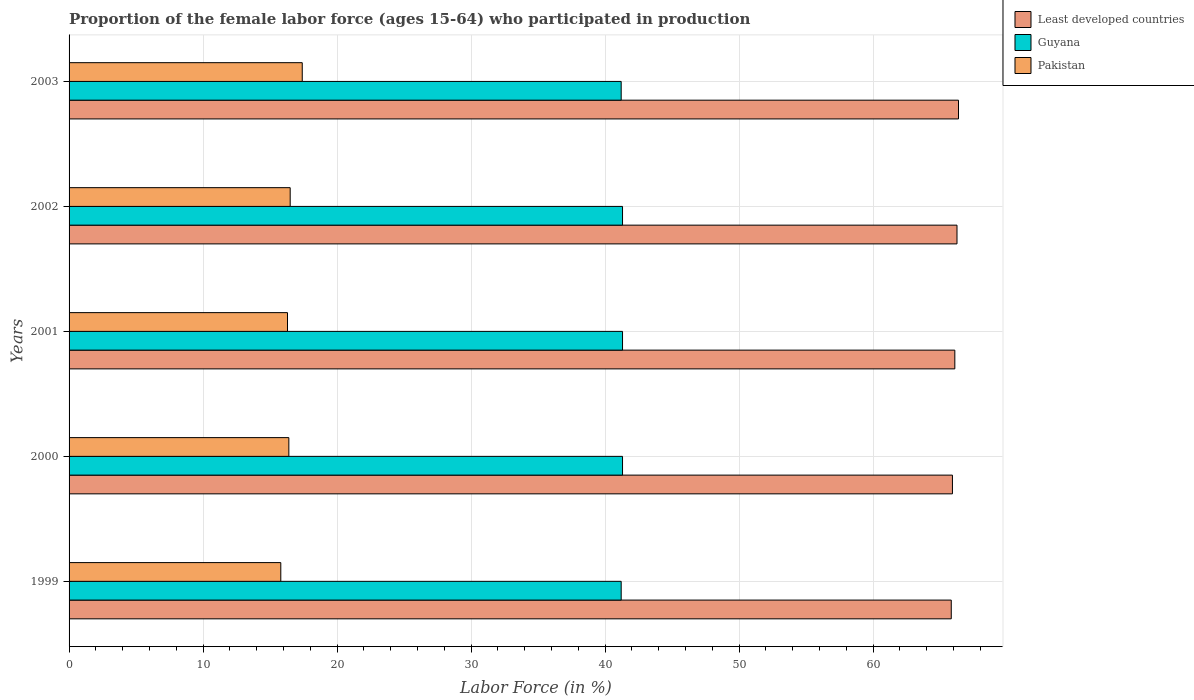Are the number of bars on each tick of the Y-axis equal?
Give a very brief answer. Yes. How many bars are there on the 3rd tick from the top?
Ensure brevity in your answer.  3. How many bars are there on the 3rd tick from the bottom?
Offer a terse response. 3. In how many cases, is the number of bars for a given year not equal to the number of legend labels?
Make the answer very short. 0. What is the proportion of the female labor force who participated in production in Least developed countries in 2000?
Provide a succinct answer. 65.92. Across all years, what is the maximum proportion of the female labor force who participated in production in Pakistan?
Your response must be concise. 17.4. Across all years, what is the minimum proportion of the female labor force who participated in production in Guyana?
Ensure brevity in your answer.  41.2. In which year was the proportion of the female labor force who participated in production in Least developed countries maximum?
Provide a short and direct response. 2003. What is the total proportion of the female labor force who participated in production in Least developed countries in the graph?
Offer a terse response. 330.48. What is the difference between the proportion of the female labor force who participated in production in Pakistan in 1999 and that in 2003?
Your answer should be very brief. -1.6. What is the difference between the proportion of the female labor force who participated in production in Guyana in 1999 and the proportion of the female labor force who participated in production in Least developed countries in 2002?
Offer a terse response. -25.06. What is the average proportion of the female labor force who participated in production in Least developed countries per year?
Make the answer very short. 66.1. In the year 2002, what is the difference between the proportion of the female labor force who participated in production in Least developed countries and proportion of the female labor force who participated in production in Pakistan?
Provide a short and direct response. 49.76. In how many years, is the proportion of the female labor force who participated in production in Pakistan greater than 36 %?
Your answer should be compact. 0. What is the ratio of the proportion of the female labor force who participated in production in Least developed countries in 1999 to that in 2000?
Your response must be concise. 1. What is the difference between the highest and the second highest proportion of the female labor force who participated in production in Pakistan?
Make the answer very short. 0.9. What is the difference between the highest and the lowest proportion of the female labor force who participated in production in Pakistan?
Your answer should be compact. 1.6. In how many years, is the proportion of the female labor force who participated in production in Guyana greater than the average proportion of the female labor force who participated in production in Guyana taken over all years?
Provide a succinct answer. 3. What does the 2nd bar from the top in 2002 represents?
Your response must be concise. Guyana. What does the 2nd bar from the bottom in 2002 represents?
Provide a succinct answer. Guyana. How many bars are there?
Offer a terse response. 15. Are all the bars in the graph horizontal?
Your answer should be compact. Yes. Are the values on the major ticks of X-axis written in scientific E-notation?
Provide a short and direct response. No. Does the graph contain grids?
Give a very brief answer. Yes. Where does the legend appear in the graph?
Make the answer very short. Top right. What is the title of the graph?
Make the answer very short. Proportion of the female labor force (ages 15-64) who participated in production. What is the label or title of the Y-axis?
Provide a short and direct response. Years. What is the Labor Force (in %) of Least developed countries in 1999?
Your answer should be very brief. 65.83. What is the Labor Force (in %) in Guyana in 1999?
Keep it short and to the point. 41.2. What is the Labor Force (in %) in Pakistan in 1999?
Offer a very short reply. 15.8. What is the Labor Force (in %) in Least developed countries in 2000?
Make the answer very short. 65.92. What is the Labor Force (in %) in Guyana in 2000?
Offer a terse response. 41.3. What is the Labor Force (in %) in Pakistan in 2000?
Your answer should be very brief. 16.4. What is the Labor Force (in %) of Least developed countries in 2001?
Offer a very short reply. 66.1. What is the Labor Force (in %) in Guyana in 2001?
Give a very brief answer. 41.3. What is the Labor Force (in %) of Pakistan in 2001?
Keep it short and to the point. 16.3. What is the Labor Force (in %) of Least developed countries in 2002?
Provide a succinct answer. 66.26. What is the Labor Force (in %) of Guyana in 2002?
Give a very brief answer. 41.3. What is the Labor Force (in %) in Pakistan in 2002?
Provide a succinct answer. 16.5. What is the Labor Force (in %) of Least developed countries in 2003?
Your answer should be very brief. 66.37. What is the Labor Force (in %) of Guyana in 2003?
Offer a terse response. 41.2. What is the Labor Force (in %) in Pakistan in 2003?
Keep it short and to the point. 17.4. Across all years, what is the maximum Labor Force (in %) in Least developed countries?
Provide a short and direct response. 66.37. Across all years, what is the maximum Labor Force (in %) of Guyana?
Provide a succinct answer. 41.3. Across all years, what is the maximum Labor Force (in %) in Pakistan?
Provide a succinct answer. 17.4. Across all years, what is the minimum Labor Force (in %) in Least developed countries?
Your answer should be very brief. 65.83. Across all years, what is the minimum Labor Force (in %) of Guyana?
Offer a very short reply. 41.2. Across all years, what is the minimum Labor Force (in %) in Pakistan?
Offer a terse response. 15.8. What is the total Labor Force (in %) in Least developed countries in the graph?
Your answer should be very brief. 330.48. What is the total Labor Force (in %) of Guyana in the graph?
Your response must be concise. 206.3. What is the total Labor Force (in %) of Pakistan in the graph?
Your response must be concise. 82.4. What is the difference between the Labor Force (in %) of Least developed countries in 1999 and that in 2000?
Your answer should be very brief. -0.09. What is the difference between the Labor Force (in %) in Pakistan in 1999 and that in 2000?
Give a very brief answer. -0.6. What is the difference between the Labor Force (in %) in Least developed countries in 1999 and that in 2001?
Your response must be concise. -0.27. What is the difference between the Labor Force (in %) of Pakistan in 1999 and that in 2001?
Keep it short and to the point. -0.5. What is the difference between the Labor Force (in %) of Least developed countries in 1999 and that in 2002?
Your response must be concise. -0.43. What is the difference between the Labor Force (in %) of Guyana in 1999 and that in 2002?
Offer a very short reply. -0.1. What is the difference between the Labor Force (in %) of Pakistan in 1999 and that in 2002?
Offer a very short reply. -0.7. What is the difference between the Labor Force (in %) in Least developed countries in 1999 and that in 2003?
Your answer should be very brief. -0.54. What is the difference between the Labor Force (in %) of Least developed countries in 2000 and that in 2001?
Your response must be concise. -0.18. What is the difference between the Labor Force (in %) of Least developed countries in 2000 and that in 2002?
Offer a very short reply. -0.34. What is the difference between the Labor Force (in %) in Guyana in 2000 and that in 2002?
Offer a very short reply. 0. What is the difference between the Labor Force (in %) in Least developed countries in 2000 and that in 2003?
Give a very brief answer. -0.45. What is the difference between the Labor Force (in %) in Guyana in 2000 and that in 2003?
Give a very brief answer. 0.1. What is the difference between the Labor Force (in %) in Least developed countries in 2001 and that in 2002?
Your answer should be very brief. -0.16. What is the difference between the Labor Force (in %) of Guyana in 2001 and that in 2002?
Ensure brevity in your answer.  0. What is the difference between the Labor Force (in %) in Pakistan in 2001 and that in 2002?
Make the answer very short. -0.2. What is the difference between the Labor Force (in %) in Least developed countries in 2001 and that in 2003?
Ensure brevity in your answer.  -0.27. What is the difference between the Labor Force (in %) of Guyana in 2001 and that in 2003?
Provide a succinct answer. 0.1. What is the difference between the Labor Force (in %) in Least developed countries in 2002 and that in 2003?
Provide a succinct answer. -0.11. What is the difference between the Labor Force (in %) of Guyana in 2002 and that in 2003?
Provide a succinct answer. 0.1. What is the difference between the Labor Force (in %) in Least developed countries in 1999 and the Labor Force (in %) in Guyana in 2000?
Your answer should be very brief. 24.53. What is the difference between the Labor Force (in %) of Least developed countries in 1999 and the Labor Force (in %) of Pakistan in 2000?
Your answer should be compact. 49.43. What is the difference between the Labor Force (in %) in Guyana in 1999 and the Labor Force (in %) in Pakistan in 2000?
Give a very brief answer. 24.8. What is the difference between the Labor Force (in %) of Least developed countries in 1999 and the Labor Force (in %) of Guyana in 2001?
Ensure brevity in your answer.  24.53. What is the difference between the Labor Force (in %) in Least developed countries in 1999 and the Labor Force (in %) in Pakistan in 2001?
Offer a terse response. 49.53. What is the difference between the Labor Force (in %) in Guyana in 1999 and the Labor Force (in %) in Pakistan in 2001?
Your answer should be very brief. 24.9. What is the difference between the Labor Force (in %) of Least developed countries in 1999 and the Labor Force (in %) of Guyana in 2002?
Offer a very short reply. 24.53. What is the difference between the Labor Force (in %) of Least developed countries in 1999 and the Labor Force (in %) of Pakistan in 2002?
Keep it short and to the point. 49.33. What is the difference between the Labor Force (in %) in Guyana in 1999 and the Labor Force (in %) in Pakistan in 2002?
Your answer should be very brief. 24.7. What is the difference between the Labor Force (in %) of Least developed countries in 1999 and the Labor Force (in %) of Guyana in 2003?
Keep it short and to the point. 24.63. What is the difference between the Labor Force (in %) of Least developed countries in 1999 and the Labor Force (in %) of Pakistan in 2003?
Keep it short and to the point. 48.43. What is the difference between the Labor Force (in %) of Guyana in 1999 and the Labor Force (in %) of Pakistan in 2003?
Make the answer very short. 23.8. What is the difference between the Labor Force (in %) in Least developed countries in 2000 and the Labor Force (in %) in Guyana in 2001?
Keep it short and to the point. 24.62. What is the difference between the Labor Force (in %) in Least developed countries in 2000 and the Labor Force (in %) in Pakistan in 2001?
Your answer should be very brief. 49.62. What is the difference between the Labor Force (in %) in Guyana in 2000 and the Labor Force (in %) in Pakistan in 2001?
Ensure brevity in your answer.  25. What is the difference between the Labor Force (in %) in Least developed countries in 2000 and the Labor Force (in %) in Guyana in 2002?
Provide a succinct answer. 24.62. What is the difference between the Labor Force (in %) in Least developed countries in 2000 and the Labor Force (in %) in Pakistan in 2002?
Your answer should be compact. 49.42. What is the difference between the Labor Force (in %) of Guyana in 2000 and the Labor Force (in %) of Pakistan in 2002?
Provide a succinct answer. 24.8. What is the difference between the Labor Force (in %) in Least developed countries in 2000 and the Labor Force (in %) in Guyana in 2003?
Your answer should be very brief. 24.72. What is the difference between the Labor Force (in %) in Least developed countries in 2000 and the Labor Force (in %) in Pakistan in 2003?
Your answer should be very brief. 48.52. What is the difference between the Labor Force (in %) of Guyana in 2000 and the Labor Force (in %) of Pakistan in 2003?
Keep it short and to the point. 23.9. What is the difference between the Labor Force (in %) in Least developed countries in 2001 and the Labor Force (in %) in Guyana in 2002?
Your answer should be compact. 24.8. What is the difference between the Labor Force (in %) in Least developed countries in 2001 and the Labor Force (in %) in Pakistan in 2002?
Offer a very short reply. 49.6. What is the difference between the Labor Force (in %) of Guyana in 2001 and the Labor Force (in %) of Pakistan in 2002?
Give a very brief answer. 24.8. What is the difference between the Labor Force (in %) in Least developed countries in 2001 and the Labor Force (in %) in Guyana in 2003?
Ensure brevity in your answer.  24.9. What is the difference between the Labor Force (in %) of Least developed countries in 2001 and the Labor Force (in %) of Pakistan in 2003?
Provide a succinct answer. 48.7. What is the difference between the Labor Force (in %) of Guyana in 2001 and the Labor Force (in %) of Pakistan in 2003?
Provide a succinct answer. 23.9. What is the difference between the Labor Force (in %) in Least developed countries in 2002 and the Labor Force (in %) in Guyana in 2003?
Offer a very short reply. 25.06. What is the difference between the Labor Force (in %) of Least developed countries in 2002 and the Labor Force (in %) of Pakistan in 2003?
Your answer should be very brief. 48.86. What is the difference between the Labor Force (in %) in Guyana in 2002 and the Labor Force (in %) in Pakistan in 2003?
Your answer should be very brief. 23.9. What is the average Labor Force (in %) in Least developed countries per year?
Provide a succinct answer. 66.1. What is the average Labor Force (in %) of Guyana per year?
Give a very brief answer. 41.26. What is the average Labor Force (in %) of Pakistan per year?
Keep it short and to the point. 16.48. In the year 1999, what is the difference between the Labor Force (in %) in Least developed countries and Labor Force (in %) in Guyana?
Make the answer very short. 24.63. In the year 1999, what is the difference between the Labor Force (in %) in Least developed countries and Labor Force (in %) in Pakistan?
Your answer should be compact. 50.03. In the year 1999, what is the difference between the Labor Force (in %) of Guyana and Labor Force (in %) of Pakistan?
Ensure brevity in your answer.  25.4. In the year 2000, what is the difference between the Labor Force (in %) in Least developed countries and Labor Force (in %) in Guyana?
Provide a succinct answer. 24.62. In the year 2000, what is the difference between the Labor Force (in %) in Least developed countries and Labor Force (in %) in Pakistan?
Provide a succinct answer. 49.52. In the year 2000, what is the difference between the Labor Force (in %) of Guyana and Labor Force (in %) of Pakistan?
Give a very brief answer. 24.9. In the year 2001, what is the difference between the Labor Force (in %) of Least developed countries and Labor Force (in %) of Guyana?
Provide a short and direct response. 24.8. In the year 2001, what is the difference between the Labor Force (in %) of Least developed countries and Labor Force (in %) of Pakistan?
Your answer should be compact. 49.8. In the year 2002, what is the difference between the Labor Force (in %) in Least developed countries and Labor Force (in %) in Guyana?
Your answer should be compact. 24.96. In the year 2002, what is the difference between the Labor Force (in %) of Least developed countries and Labor Force (in %) of Pakistan?
Your answer should be compact. 49.76. In the year 2002, what is the difference between the Labor Force (in %) in Guyana and Labor Force (in %) in Pakistan?
Provide a succinct answer. 24.8. In the year 2003, what is the difference between the Labor Force (in %) in Least developed countries and Labor Force (in %) in Guyana?
Provide a short and direct response. 25.17. In the year 2003, what is the difference between the Labor Force (in %) in Least developed countries and Labor Force (in %) in Pakistan?
Give a very brief answer. 48.97. In the year 2003, what is the difference between the Labor Force (in %) in Guyana and Labor Force (in %) in Pakistan?
Your response must be concise. 23.8. What is the ratio of the Labor Force (in %) of Guyana in 1999 to that in 2000?
Ensure brevity in your answer.  1. What is the ratio of the Labor Force (in %) of Pakistan in 1999 to that in 2000?
Your answer should be very brief. 0.96. What is the ratio of the Labor Force (in %) of Pakistan in 1999 to that in 2001?
Offer a terse response. 0.97. What is the ratio of the Labor Force (in %) of Pakistan in 1999 to that in 2002?
Ensure brevity in your answer.  0.96. What is the ratio of the Labor Force (in %) in Guyana in 1999 to that in 2003?
Make the answer very short. 1. What is the ratio of the Labor Force (in %) in Pakistan in 1999 to that in 2003?
Your answer should be very brief. 0.91. What is the ratio of the Labor Force (in %) of Guyana in 2000 to that in 2001?
Ensure brevity in your answer.  1. What is the ratio of the Labor Force (in %) of Least developed countries in 2000 to that in 2002?
Your answer should be compact. 0.99. What is the ratio of the Labor Force (in %) of Guyana in 2000 to that in 2002?
Offer a terse response. 1. What is the ratio of the Labor Force (in %) in Least developed countries in 2000 to that in 2003?
Make the answer very short. 0.99. What is the ratio of the Labor Force (in %) of Pakistan in 2000 to that in 2003?
Your answer should be very brief. 0.94. What is the ratio of the Labor Force (in %) of Least developed countries in 2001 to that in 2002?
Offer a very short reply. 1. What is the ratio of the Labor Force (in %) of Pakistan in 2001 to that in 2002?
Offer a terse response. 0.99. What is the ratio of the Labor Force (in %) of Least developed countries in 2001 to that in 2003?
Offer a terse response. 1. What is the ratio of the Labor Force (in %) in Guyana in 2001 to that in 2003?
Ensure brevity in your answer.  1. What is the ratio of the Labor Force (in %) in Pakistan in 2001 to that in 2003?
Provide a succinct answer. 0.94. What is the ratio of the Labor Force (in %) of Least developed countries in 2002 to that in 2003?
Your answer should be compact. 1. What is the ratio of the Labor Force (in %) in Guyana in 2002 to that in 2003?
Keep it short and to the point. 1. What is the ratio of the Labor Force (in %) in Pakistan in 2002 to that in 2003?
Your answer should be very brief. 0.95. What is the difference between the highest and the second highest Labor Force (in %) in Least developed countries?
Ensure brevity in your answer.  0.11. What is the difference between the highest and the lowest Labor Force (in %) in Least developed countries?
Offer a terse response. 0.54. What is the difference between the highest and the lowest Labor Force (in %) in Pakistan?
Your answer should be compact. 1.6. 